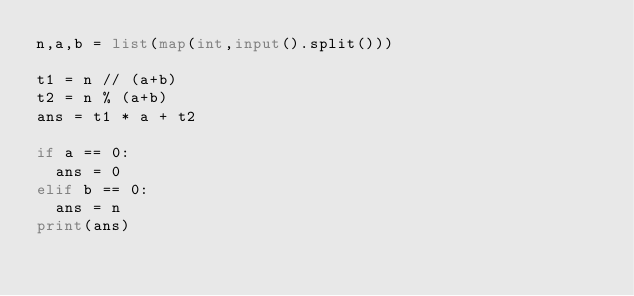<code> <loc_0><loc_0><loc_500><loc_500><_Python_>n,a,b = list(map(int,input().split()))

t1 = n // (a+b)
t2 = n % (a+b)
ans = t1 * a + t2

if a == 0:
  ans = 0
elif b == 0:
  ans = n
print(ans)
</code> 